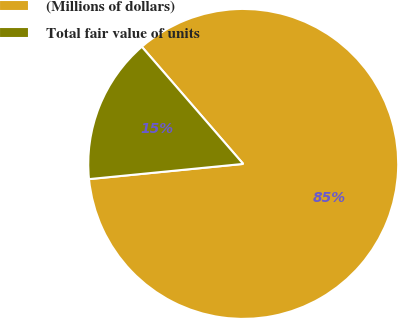Convert chart. <chart><loc_0><loc_0><loc_500><loc_500><pie_chart><fcel>(Millions of dollars)<fcel>Total fair value of units<nl><fcel>84.79%<fcel>15.21%<nl></chart> 